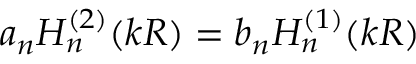<formula> <loc_0><loc_0><loc_500><loc_500>a _ { n } H _ { n } ^ { ( 2 ) } ( k R ) = b _ { n } H _ { n } ^ { ( 1 ) } ( k R )</formula> 